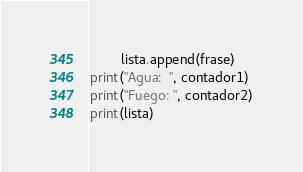<code> <loc_0><loc_0><loc_500><loc_500><_Python_>        lista.append(frase)
print("Agua:  ", contador1)
print("Fuego: ", contador2)
print(lista)
</code> 